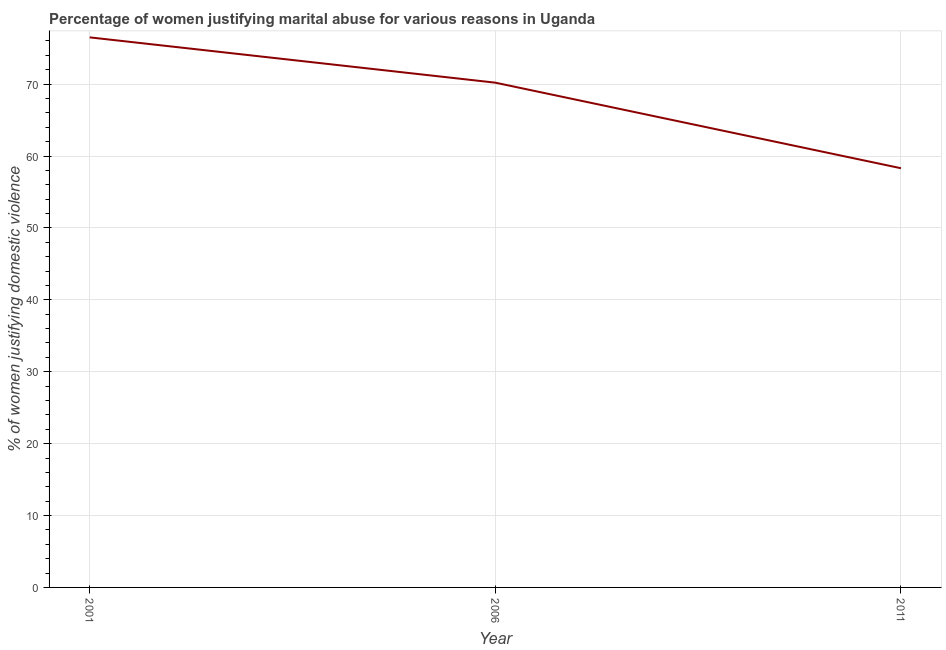What is the percentage of women justifying marital abuse in 2006?
Provide a succinct answer. 70.2. Across all years, what is the maximum percentage of women justifying marital abuse?
Your answer should be very brief. 76.5. Across all years, what is the minimum percentage of women justifying marital abuse?
Provide a succinct answer. 58.3. In which year was the percentage of women justifying marital abuse minimum?
Ensure brevity in your answer.  2011. What is the sum of the percentage of women justifying marital abuse?
Make the answer very short. 205. What is the difference between the percentage of women justifying marital abuse in 2001 and 2006?
Give a very brief answer. 6.3. What is the average percentage of women justifying marital abuse per year?
Make the answer very short. 68.33. What is the median percentage of women justifying marital abuse?
Ensure brevity in your answer.  70.2. In how many years, is the percentage of women justifying marital abuse greater than 24 %?
Make the answer very short. 3. Do a majority of the years between 2001 and 2011 (inclusive) have percentage of women justifying marital abuse greater than 30 %?
Your answer should be very brief. Yes. What is the ratio of the percentage of women justifying marital abuse in 2006 to that in 2011?
Provide a short and direct response. 1.2. What is the difference between the highest and the second highest percentage of women justifying marital abuse?
Your answer should be compact. 6.3. Is the sum of the percentage of women justifying marital abuse in 2001 and 2006 greater than the maximum percentage of women justifying marital abuse across all years?
Give a very brief answer. Yes. What is the difference between the highest and the lowest percentage of women justifying marital abuse?
Make the answer very short. 18.2. Does the percentage of women justifying marital abuse monotonically increase over the years?
Provide a succinct answer. No. How many lines are there?
Keep it short and to the point. 1. How many years are there in the graph?
Your response must be concise. 3. Are the values on the major ticks of Y-axis written in scientific E-notation?
Your response must be concise. No. What is the title of the graph?
Offer a very short reply. Percentage of women justifying marital abuse for various reasons in Uganda. What is the label or title of the X-axis?
Your answer should be compact. Year. What is the label or title of the Y-axis?
Your answer should be very brief. % of women justifying domestic violence. What is the % of women justifying domestic violence of 2001?
Provide a succinct answer. 76.5. What is the % of women justifying domestic violence of 2006?
Make the answer very short. 70.2. What is the % of women justifying domestic violence of 2011?
Offer a terse response. 58.3. What is the difference between the % of women justifying domestic violence in 2001 and 2006?
Your response must be concise. 6.3. What is the difference between the % of women justifying domestic violence in 2001 and 2011?
Give a very brief answer. 18.2. What is the difference between the % of women justifying domestic violence in 2006 and 2011?
Give a very brief answer. 11.9. What is the ratio of the % of women justifying domestic violence in 2001 to that in 2006?
Provide a succinct answer. 1.09. What is the ratio of the % of women justifying domestic violence in 2001 to that in 2011?
Offer a very short reply. 1.31. What is the ratio of the % of women justifying domestic violence in 2006 to that in 2011?
Ensure brevity in your answer.  1.2. 